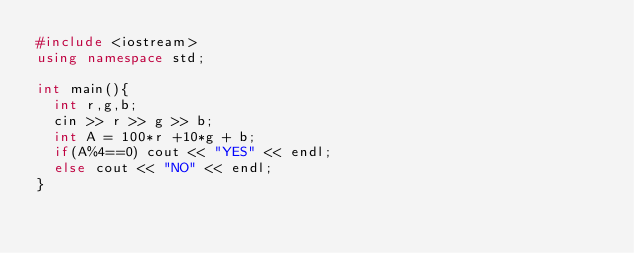Convert code to text. <code><loc_0><loc_0><loc_500><loc_500><_C++_>#include <iostream>
using namespace std;

int main(){
  int r,g,b;
  cin >> r >> g >> b;
  int A = 100*r +10*g + b;
  if(A%4==0) cout << "YES" << endl;
  else cout << "NO" << endl;
}
</code> 